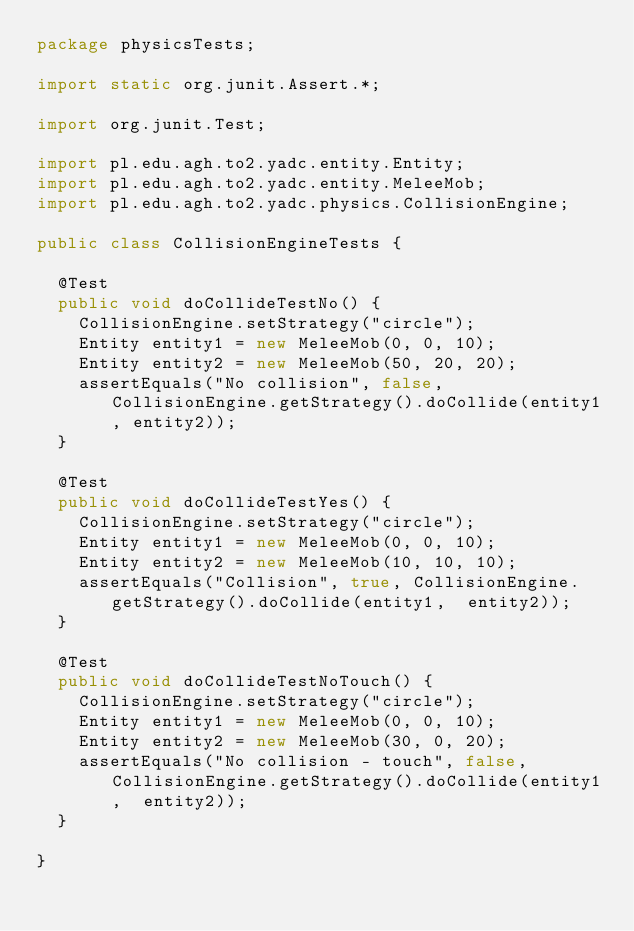Convert code to text. <code><loc_0><loc_0><loc_500><loc_500><_Java_>package physicsTests;

import static org.junit.Assert.*;

import org.junit.Test;

import pl.edu.agh.to2.yadc.entity.Entity;
import pl.edu.agh.to2.yadc.entity.MeleeMob;
import pl.edu.agh.to2.yadc.physics.CollisionEngine;

public class CollisionEngineTests {

	@Test
	public void doCollideTestNo() {
		CollisionEngine.setStrategy("circle");
		Entity entity1 = new MeleeMob(0, 0, 10);
		Entity entity2 = new MeleeMob(50, 20, 20);
		assertEquals("No collision", false, CollisionEngine.getStrategy().doCollide(entity1, entity2));
	}
	
	@Test
	public void doCollideTestYes() {
		CollisionEngine.setStrategy("circle");
		Entity entity1 = new MeleeMob(0, 0, 10);
		Entity entity2 = new MeleeMob(10, 10, 10);
		assertEquals("Collision", true, CollisionEngine.getStrategy().doCollide(entity1,  entity2));
	}
	
	@Test
	public void doCollideTestNoTouch() {
		CollisionEngine.setStrategy("circle");
		Entity entity1 = new MeleeMob(0, 0, 10);
		Entity entity2 = new MeleeMob(30, 0, 20);
		assertEquals("No collision - touch", false, CollisionEngine.getStrategy().doCollide(entity1,  entity2));
	}

}
</code> 